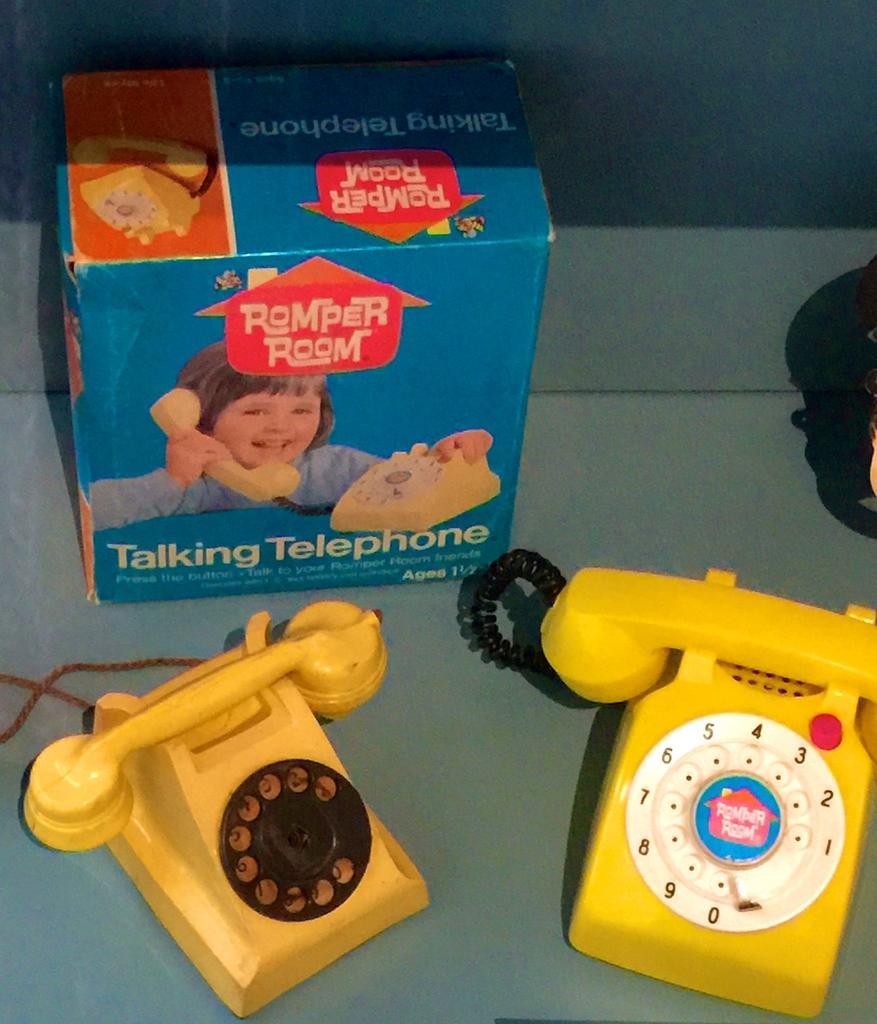Could you give a brief overview of what you see in this image? In this picture I can see at the bottom there are telephones, at the top there is a box with the images on it. 